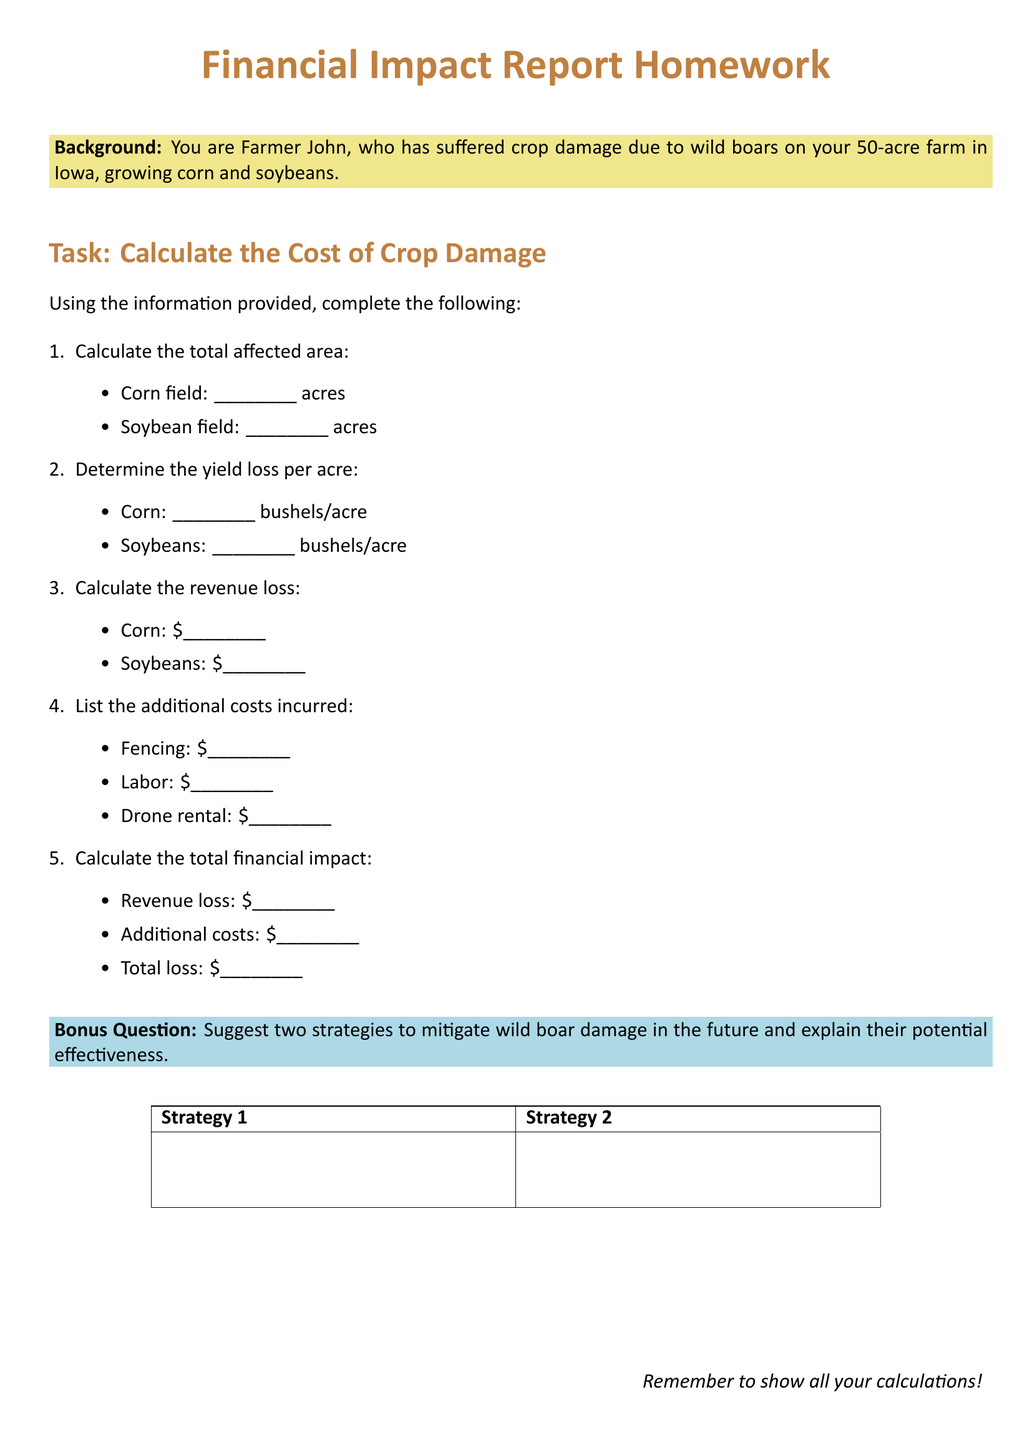What is the total affected area of corn fields? This information is a specific requirement stated in the document under the section for calculating the total affected area.
Answer: _____ acres What is the yield loss per acre for soybeans? The document asks for the calculation of yield loss per acre, specifically for soybeans.
Answer: _____ bushels/acre What is the cost of fencing incurred? This detail is listed under the additional costs incurred section in the document.
Answer: _____ What is the total revenue loss from corn? The document specifies calculating the revenue loss, particularly for corn.
Answer: _____ What are the two strategies suggested for mitigating wild boar damage? This document includes a bonus question section asking for strategic suggestions.
Answer: Strategy 1 and Strategy 2 What is the total loss calculated as? This refers to the final calculation of total financial impact mentioned towards the end of the document.
Answer: _____ How many acres are used for soybeans? The total affected area calculation section queries the soybean field specifically.
Answer: _____ acres What type of document is this? The overall format and content indicate it is a Homework assignment.
Answer: Financial Impact Report Homework What additional costs are incurred? The document explicitly lists various additional costs in the context of the financial impact.
Answer: Fencing, Labor, Drone rental 